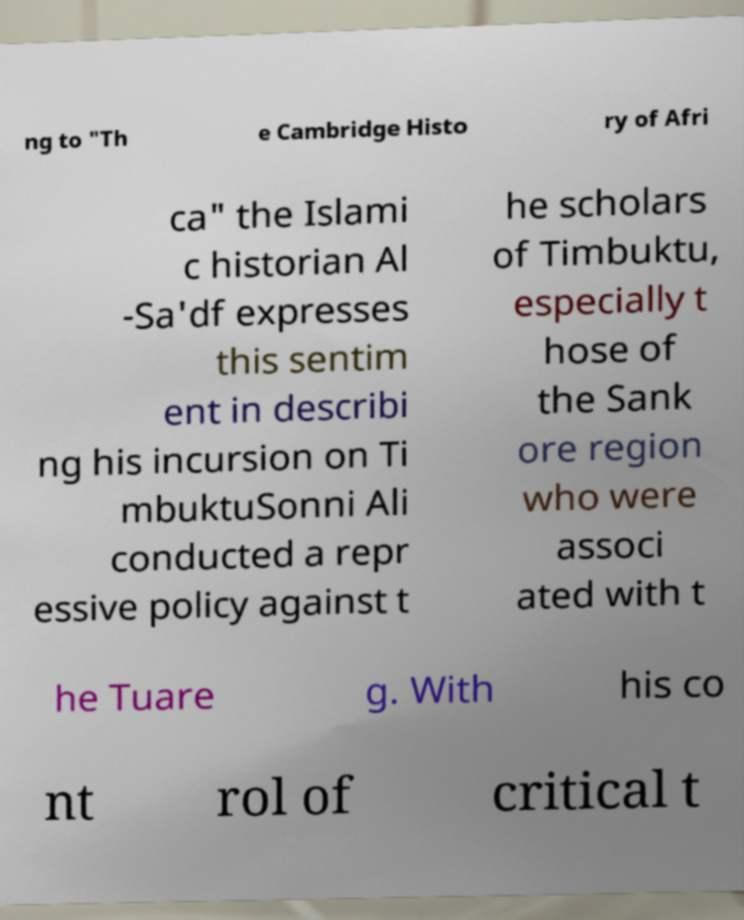Can you accurately transcribe the text from the provided image for me? ng to "Th e Cambridge Histo ry of Afri ca" the Islami c historian Al -Sa'df expresses this sentim ent in describi ng his incursion on Ti mbuktuSonni Ali conducted a repr essive policy against t he scholars of Timbuktu, especially t hose of the Sank ore region who were associ ated with t he Tuare g. With his co nt rol of critical t 